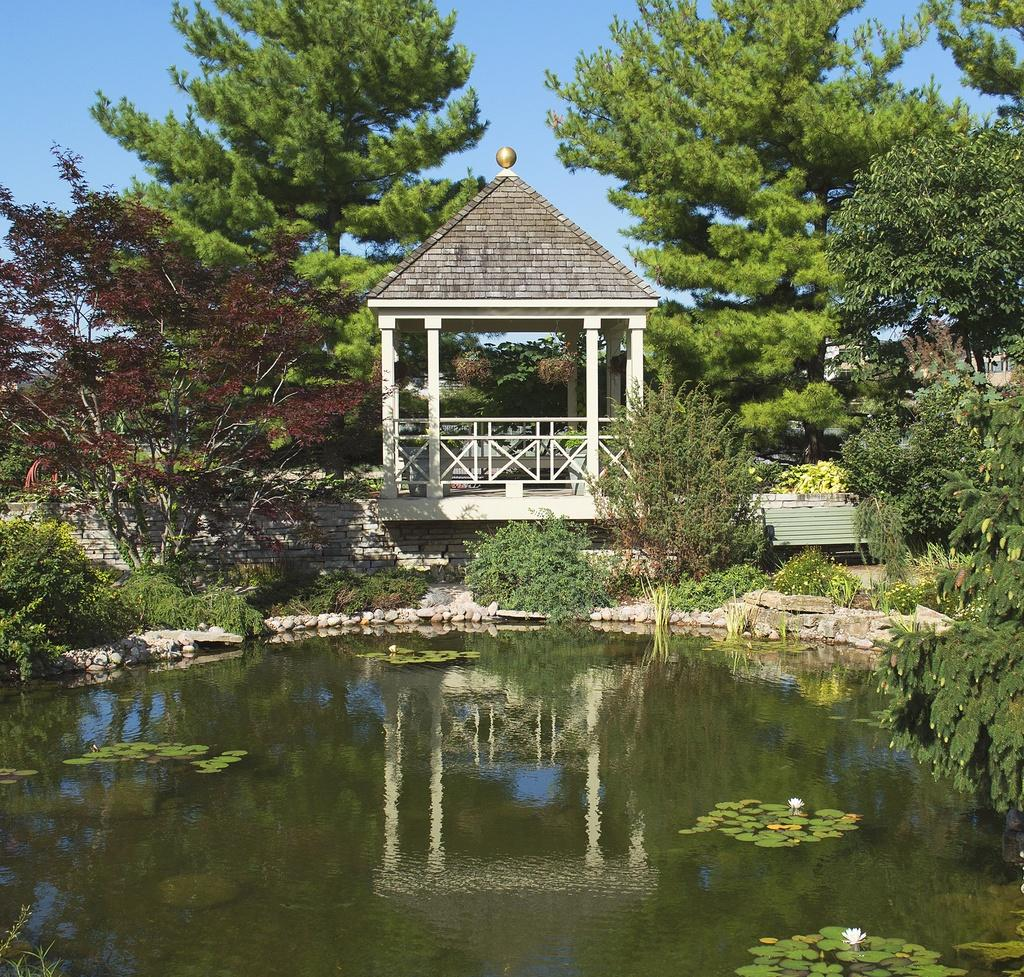What is the main feature in the foreground of the image? There is a water surface in the foreground of the image. What structure is located behind the water surface? There is a shelter behind the water surface. What type of vegetation is around the shelter? Trees are present around the shelter. How many fingers can be seen sorting the smoke in the image? There are no fingers or smoke present in the image. 